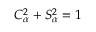Convert formula to latex. <formula><loc_0><loc_0><loc_500><loc_500>C _ { \alpha } ^ { 2 } + S _ { \alpha } ^ { 2 } = 1</formula> 